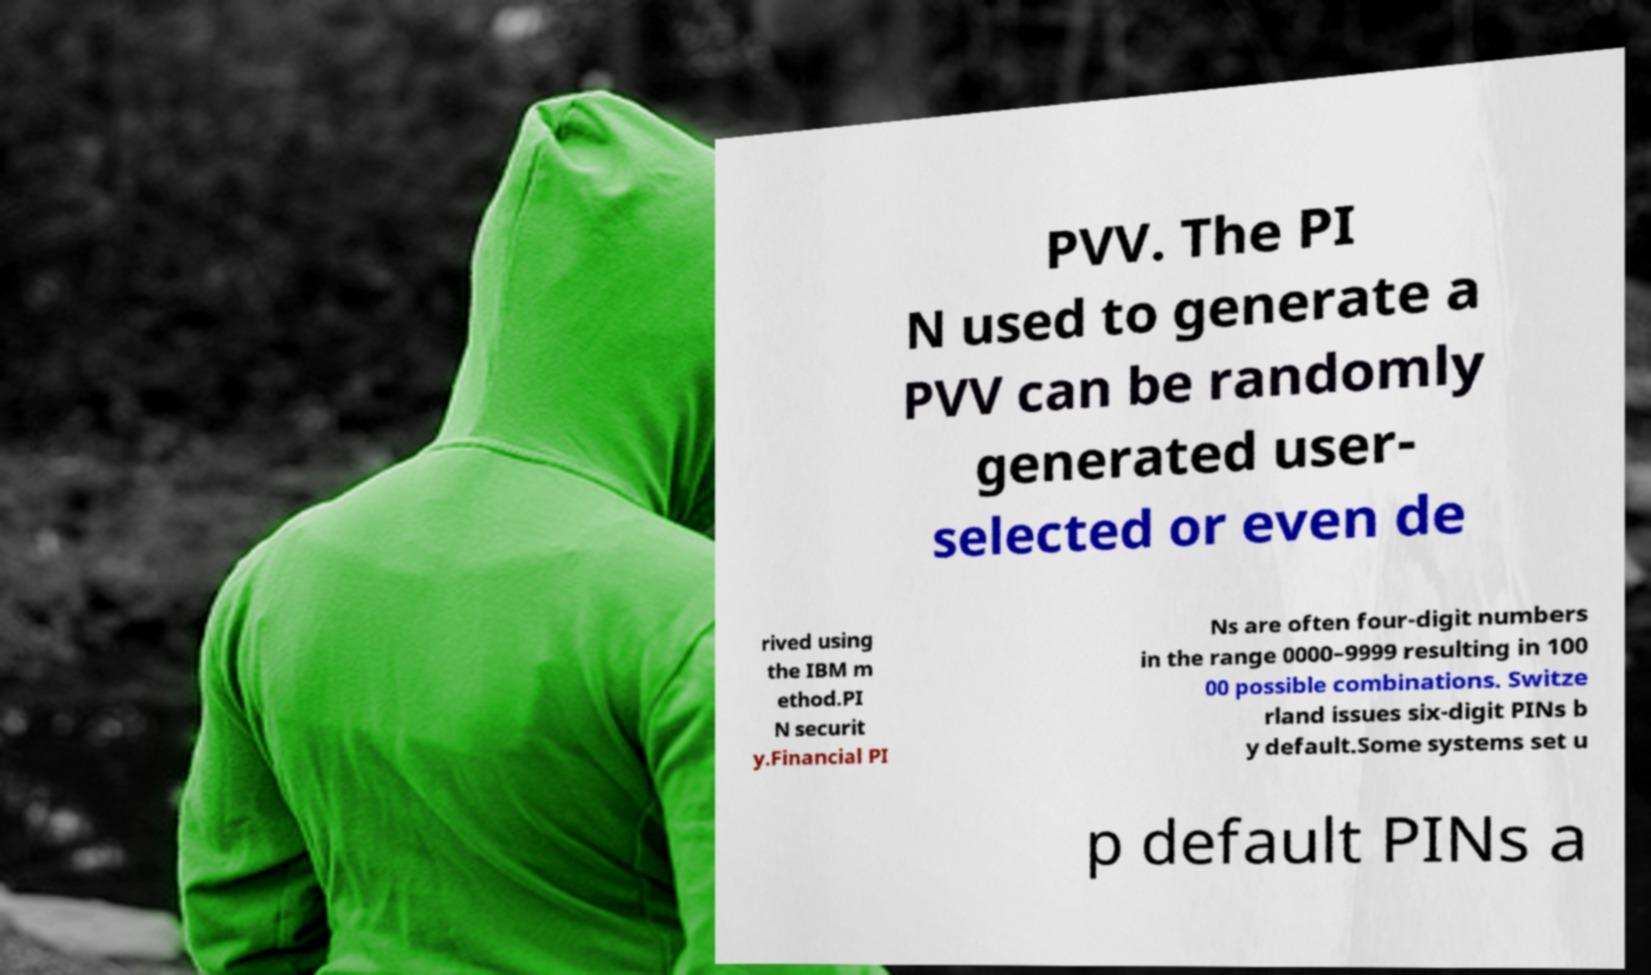I need the written content from this picture converted into text. Can you do that? PVV. The PI N used to generate a PVV can be randomly generated user- selected or even de rived using the IBM m ethod.PI N securit y.Financial PI Ns are often four-digit numbers in the range 0000–9999 resulting in 100 00 possible combinations. Switze rland issues six-digit PINs b y default.Some systems set u p default PINs a 